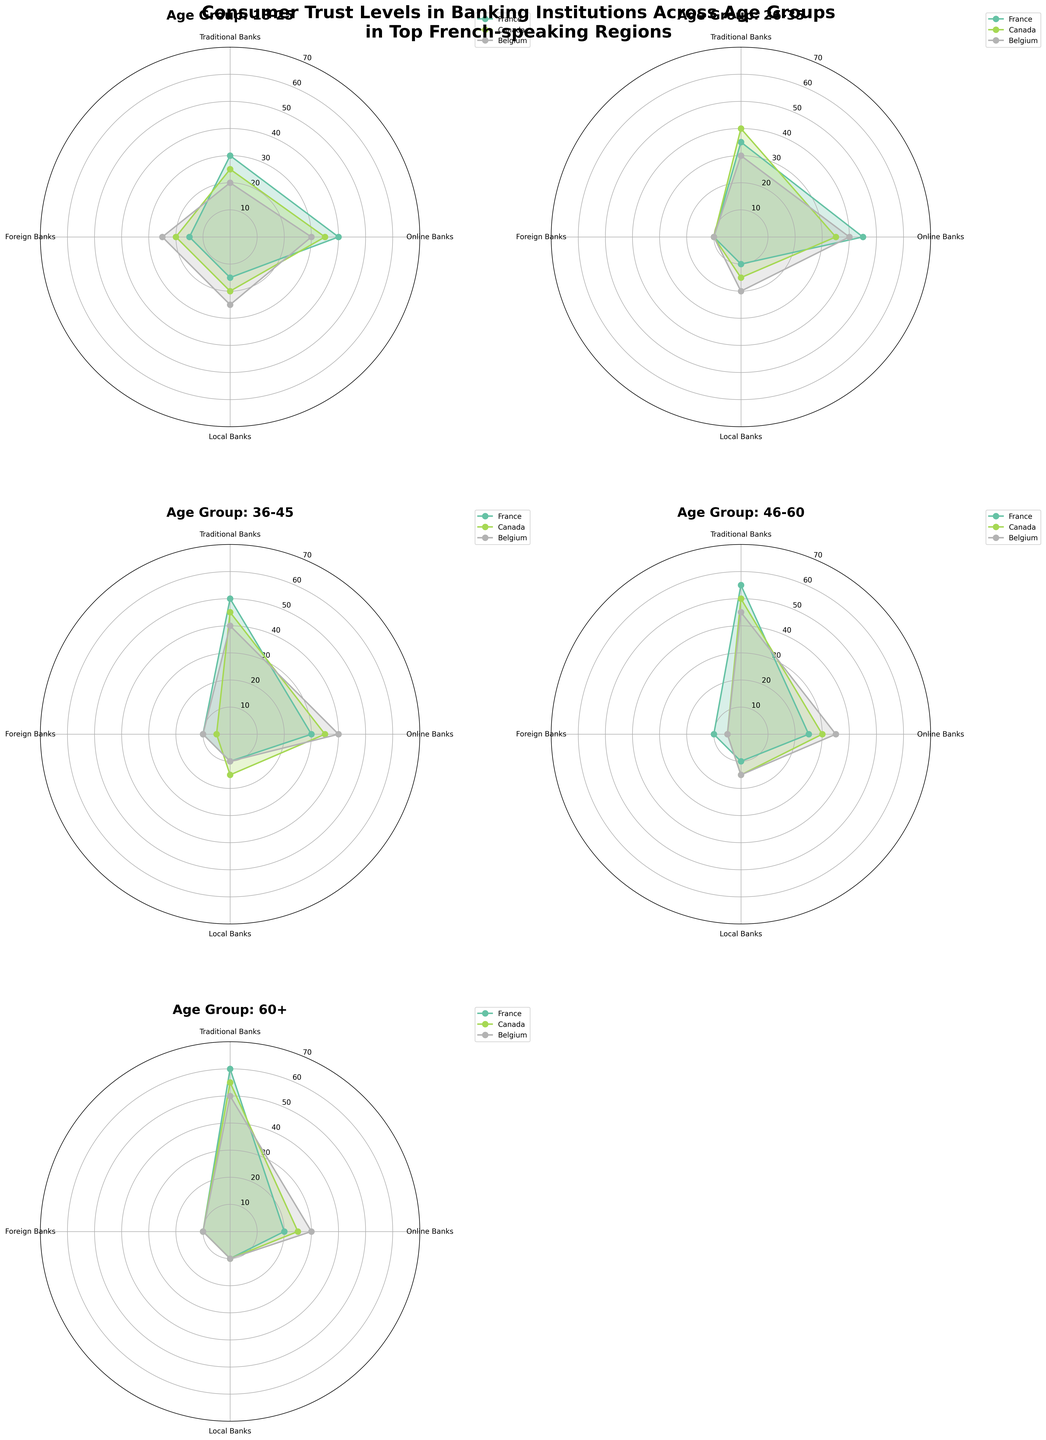What's the title of the figure? The title of the figure is the text displayed prominently at the top of the plot. It summarizes the content of the plot, indicating that it presents data on consumer trust levels in banking institutions across age groups in major French-speaking regions.
Answer: Consumer Trust Levels in Banking Institutions Across Age Groups in Top French-speaking Regions Which age group has the highest trust in traditional banks in France? By examining the subplots, we can look at the bar representing traditional banks for each age group specifically for France. The 60+ age group has the highest value for traditional banks.
Answer: 60+ age group How does consumer trust in online banks for the 18-25 age group compare across France, Canada, and Belgium? We need to compare the values for online banks among the three countries for the 18-25 age group. France shows 40, Canada shows 35, and Belgium shows 30. France has the highest trust, followed by Canada and then Belgium.
Answer: France > Canada > Belgium In the 36-45 age group, which country has the lowest trust in foreign banks? To identify the country with the lowest trust in foreign banks for the 36-45 age group, we need to compare the values for foreign banks in France, Canada, and Belgium. Canada shows the lowest value, which is 5.
Answer: Canada What's the average trust level in traditional banks for the 26-35 age group across all countries? We need to find the values for traditional banks for the 26-35 age group in France, Canada, and Belgium and then calculate the average. The values are 35 (France), 40 (Canada), and 30 (Belgium). Summing these gives 105, and dividing by 3 gives an average of 35.
Answer: 35 Which bank type shows the most consistent trust levels across all age groups in Belgium? To determine this, we look for the bank type in Belgium that has the smallest variation in trust levels across all age groups. By inspecting the plots, local banks have the values 25 (18-25), 20 (26-35), 10 (36-45), 15 (46-60), and 10 (60+). These values show relatively small variation.
Answer: Local banks For the age group 46-60 in Canada, how much higher is the trust in traditional banks compared to foreign banks? For the 46-60 age group in Canada, traditional banks have a trust level of 50, while foreign banks have a trust level of 5. The difference is 50 - 5 = 45.
Answer: 45 Are there any age groups where online banks have the highest trust compared to other bank types in any country? By examining each subplot, we look for instances where the value for online banks exceeds those of traditional, local, and foreign banks within the same country and age group. The 18-25 age group in France has 40 for online banks versus 30, 15, and 15 for traditional, local, and foreign banks respectively, making online banks the highest.
Answer: Yes, 18-25 age group in France How does trust in local banks change with age in France? To find this, we look at the values for local banks across all age groups in France. The values are 15 (18-25), 10 (26-35), 10 (36-45), 10 (46-60), and 10 (60+). Trust in local banks decreases slightly from the youngest age group and stabilizes at a constant value for the older age groups.
Answer: Decreases slightly then stabilizes 